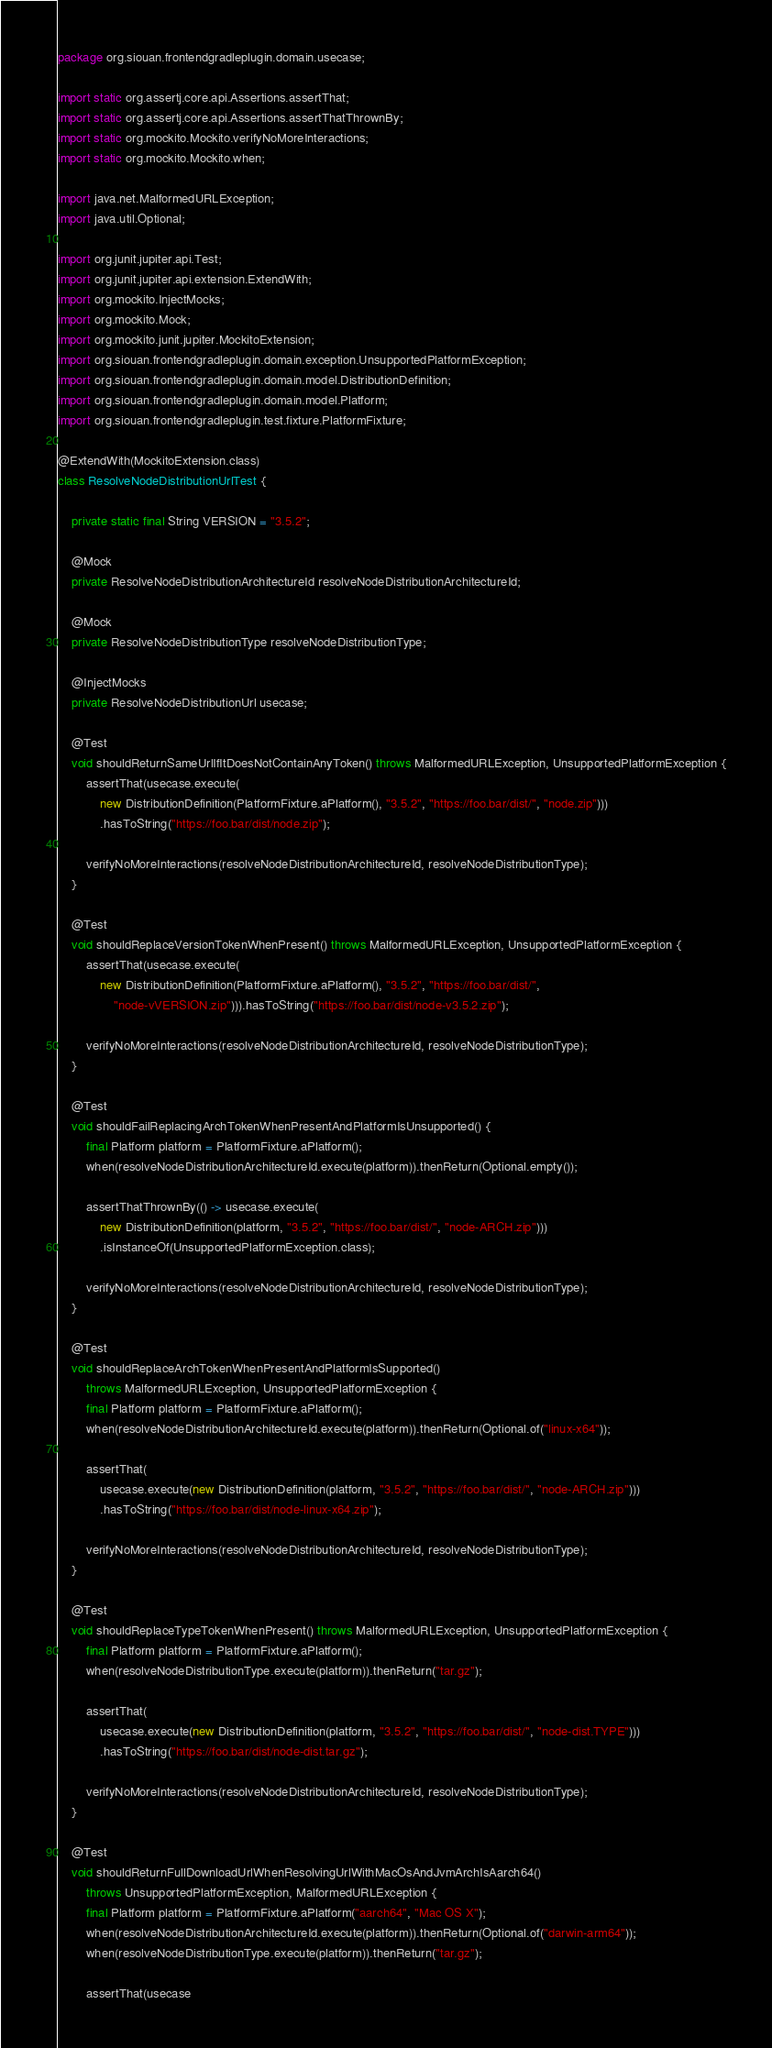<code> <loc_0><loc_0><loc_500><loc_500><_Java_>package org.siouan.frontendgradleplugin.domain.usecase;

import static org.assertj.core.api.Assertions.assertThat;
import static org.assertj.core.api.Assertions.assertThatThrownBy;
import static org.mockito.Mockito.verifyNoMoreInteractions;
import static org.mockito.Mockito.when;

import java.net.MalformedURLException;
import java.util.Optional;

import org.junit.jupiter.api.Test;
import org.junit.jupiter.api.extension.ExtendWith;
import org.mockito.InjectMocks;
import org.mockito.Mock;
import org.mockito.junit.jupiter.MockitoExtension;
import org.siouan.frontendgradleplugin.domain.exception.UnsupportedPlatformException;
import org.siouan.frontendgradleplugin.domain.model.DistributionDefinition;
import org.siouan.frontendgradleplugin.domain.model.Platform;
import org.siouan.frontendgradleplugin.test.fixture.PlatformFixture;

@ExtendWith(MockitoExtension.class)
class ResolveNodeDistributionUrlTest {

    private static final String VERSION = "3.5.2";

    @Mock
    private ResolveNodeDistributionArchitectureId resolveNodeDistributionArchitectureId;

    @Mock
    private ResolveNodeDistributionType resolveNodeDistributionType;

    @InjectMocks
    private ResolveNodeDistributionUrl usecase;

    @Test
    void shouldReturnSameUrlIfItDoesNotContainAnyToken() throws MalformedURLException, UnsupportedPlatformException {
        assertThat(usecase.execute(
            new DistributionDefinition(PlatformFixture.aPlatform(), "3.5.2", "https://foo.bar/dist/", "node.zip")))
            .hasToString("https://foo.bar/dist/node.zip");

        verifyNoMoreInteractions(resolveNodeDistributionArchitectureId, resolveNodeDistributionType);
    }

    @Test
    void shouldReplaceVersionTokenWhenPresent() throws MalformedURLException, UnsupportedPlatformException {
        assertThat(usecase.execute(
            new DistributionDefinition(PlatformFixture.aPlatform(), "3.5.2", "https://foo.bar/dist/",
                "node-vVERSION.zip"))).hasToString("https://foo.bar/dist/node-v3.5.2.zip");

        verifyNoMoreInteractions(resolveNodeDistributionArchitectureId, resolveNodeDistributionType);
    }

    @Test
    void shouldFailReplacingArchTokenWhenPresentAndPlatformIsUnsupported() {
        final Platform platform = PlatformFixture.aPlatform();
        when(resolveNodeDistributionArchitectureId.execute(platform)).thenReturn(Optional.empty());

        assertThatThrownBy(() -> usecase.execute(
            new DistributionDefinition(platform, "3.5.2", "https://foo.bar/dist/", "node-ARCH.zip")))
            .isInstanceOf(UnsupportedPlatformException.class);

        verifyNoMoreInteractions(resolveNodeDistributionArchitectureId, resolveNodeDistributionType);
    }

    @Test
    void shouldReplaceArchTokenWhenPresentAndPlatformIsSupported()
        throws MalformedURLException, UnsupportedPlatformException {
        final Platform platform = PlatformFixture.aPlatform();
        when(resolveNodeDistributionArchitectureId.execute(platform)).thenReturn(Optional.of("linux-x64"));

        assertThat(
            usecase.execute(new DistributionDefinition(platform, "3.5.2", "https://foo.bar/dist/", "node-ARCH.zip")))
            .hasToString("https://foo.bar/dist/node-linux-x64.zip");

        verifyNoMoreInteractions(resolveNodeDistributionArchitectureId, resolveNodeDistributionType);
    }

    @Test
    void shouldReplaceTypeTokenWhenPresent() throws MalformedURLException, UnsupportedPlatformException {
        final Platform platform = PlatformFixture.aPlatform();
        when(resolveNodeDistributionType.execute(platform)).thenReturn("tar.gz");

        assertThat(
            usecase.execute(new DistributionDefinition(platform, "3.5.2", "https://foo.bar/dist/", "node-dist.TYPE")))
            .hasToString("https://foo.bar/dist/node-dist.tar.gz");

        verifyNoMoreInteractions(resolveNodeDistributionArchitectureId, resolveNodeDistributionType);
    }

    @Test
    void shouldReturnFullDownloadUrlWhenResolvingUrlWithMacOsAndJvmArchIsAarch64()
        throws UnsupportedPlatformException, MalformedURLException {
        final Platform platform = PlatformFixture.aPlatform("aarch64", "Mac OS X");
        when(resolveNodeDistributionArchitectureId.execute(platform)).thenReturn(Optional.of("darwin-arm64"));
        when(resolveNodeDistributionType.execute(platform)).thenReturn("tar.gz");

        assertThat(usecase</code> 